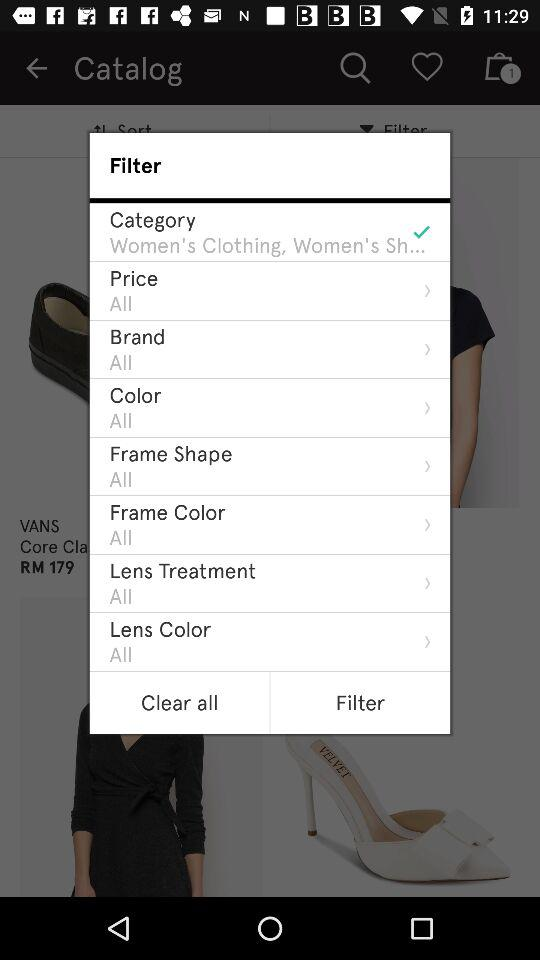How many filter options are there to choose from?
Answer the question using a single word or phrase. 8 